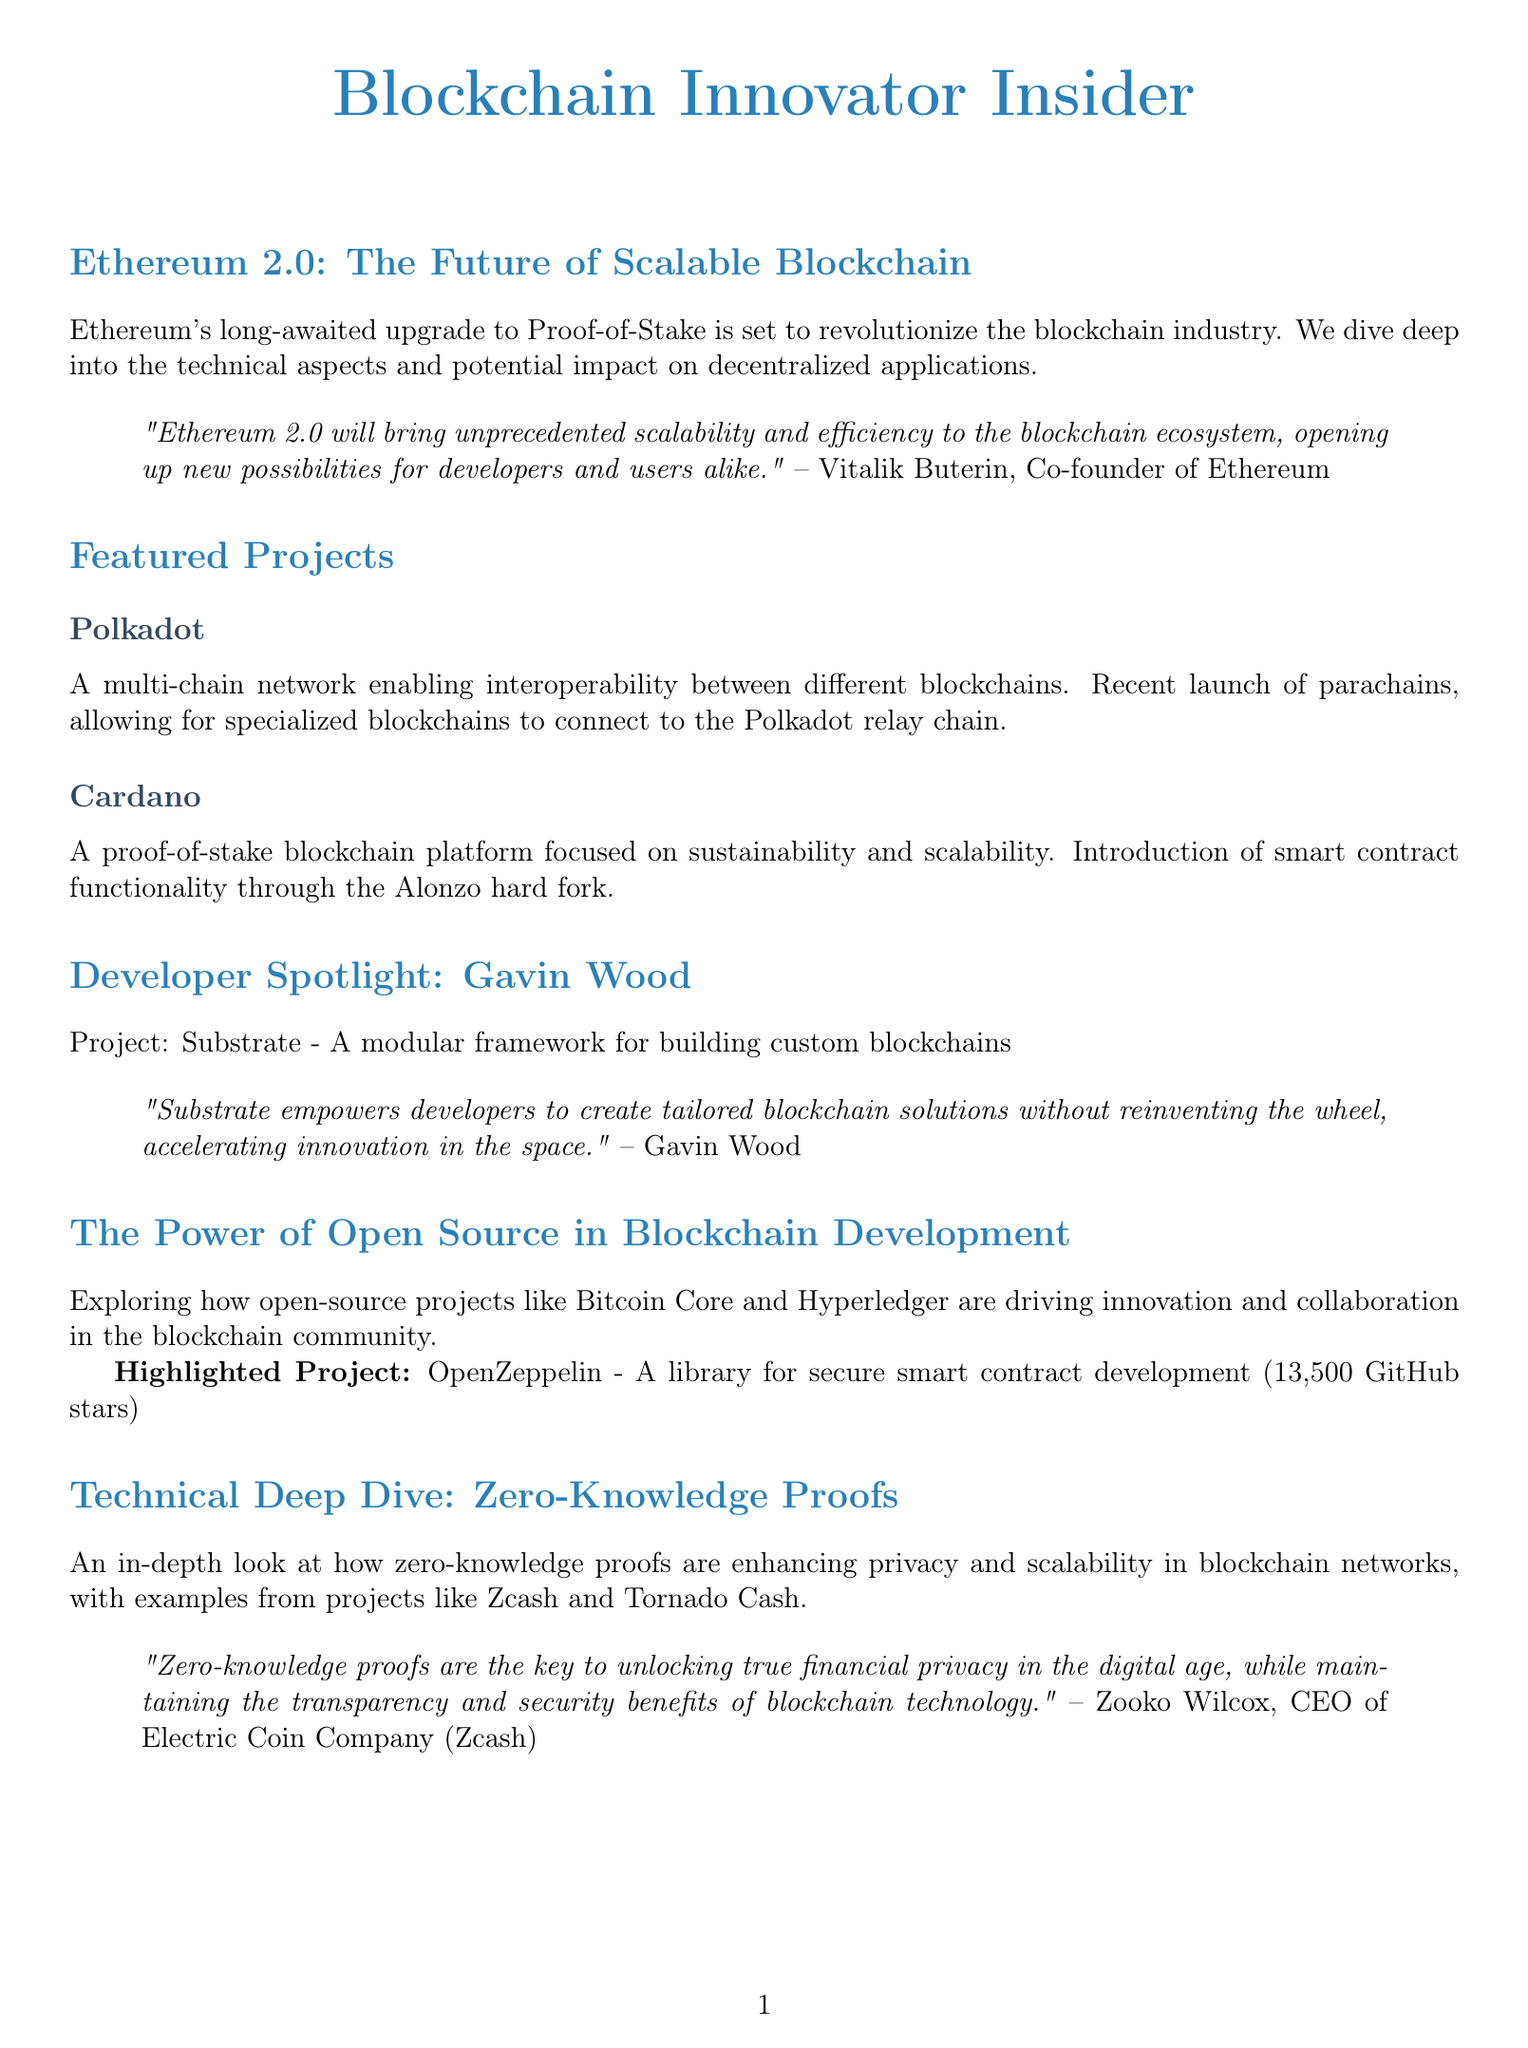What is the title of the newsletter? The title is stated at the beginning of the document.
Answer: Blockchain Innovator Insider Who is the co-founder of Ethereum mentioned in the interview? The interview section provides the name of the co-founder.
Answer: Vitalik Buterin What is the recent update for Polkadot? The document includes specific updates for each featured project.
Answer: Recent launch of parachains What is the main focus of Cardano's blockchain platform? The description of Cardano specifies its focus area.
Answer: Sustainability and scalability What is the number of GitHub stars for OpenZeppelin? The highlighted project section includes this specific metric.
Answer: 13500 What technology is discussed in the technical deep dive section? The title of the technical deep dive section indicates what technology is explored.
Answer: Zero-Knowledge Proofs What event is scheduled for October 11-14, 2023? The upcoming events list includes dates and names of events.
Answer: Devcon Who made a statement about zero-knowledge proofs? The technical deep dive section features an expert's opinion with their name.
Answer: Zooko Wilcox What project does Gavin Wood work on? The developer spotlight section identifies the project associated with Gavin Wood.
Answer: Substrate 